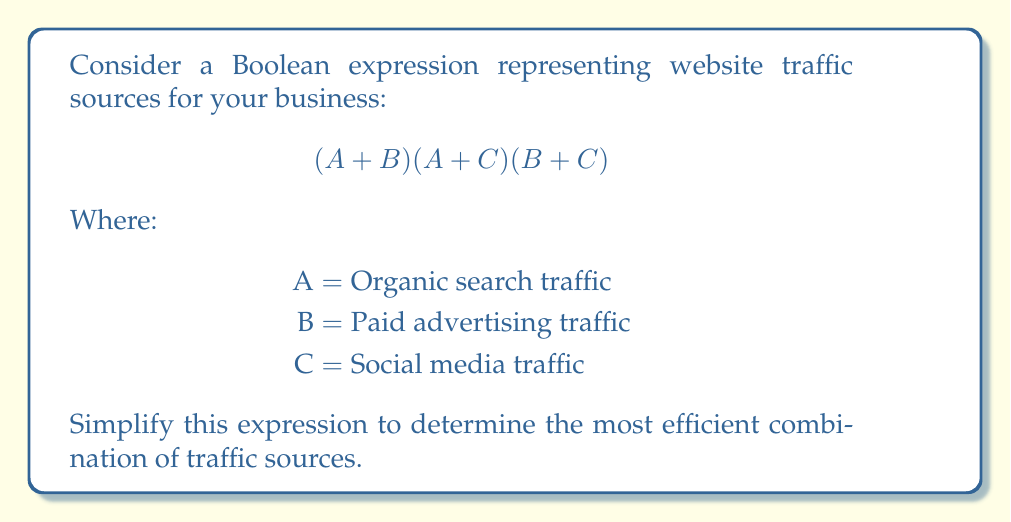Can you answer this question? Let's simplify this Boolean expression step by step:

1) First, let's expand the expression:
   $$(A + B)(A + C)(B + C)$$
   $$ = (A + B)(AB + AC + BC)$$

2) Distribute $(A + B)$ over $(AB + AC + BC)$:
   $$ = A(AB + AC + BC) + B(AB + AC + BC)$$

3) Simplify further:
   $$ = (AAB + AAC + ABC) + (ABB + ABC + BBC)$$

4) Apply the idempotent law $(AA = A, BB = B)$:
   $$ = (AB + AC + ABC) + (AB + ABC + BC)$$

5) Combine like terms:
   $$ = AB + AC + ABC + AB + ABC + BC$$
   $$ = AB + AC + BC + ABC + ABC$$

6) Apply the absorption law $(X + XY = X)$:
   $$ = AB + AC + BC$$

This simplified expression represents the most efficient combination of traffic sources.
Answer: $AB + AC + BC$ 